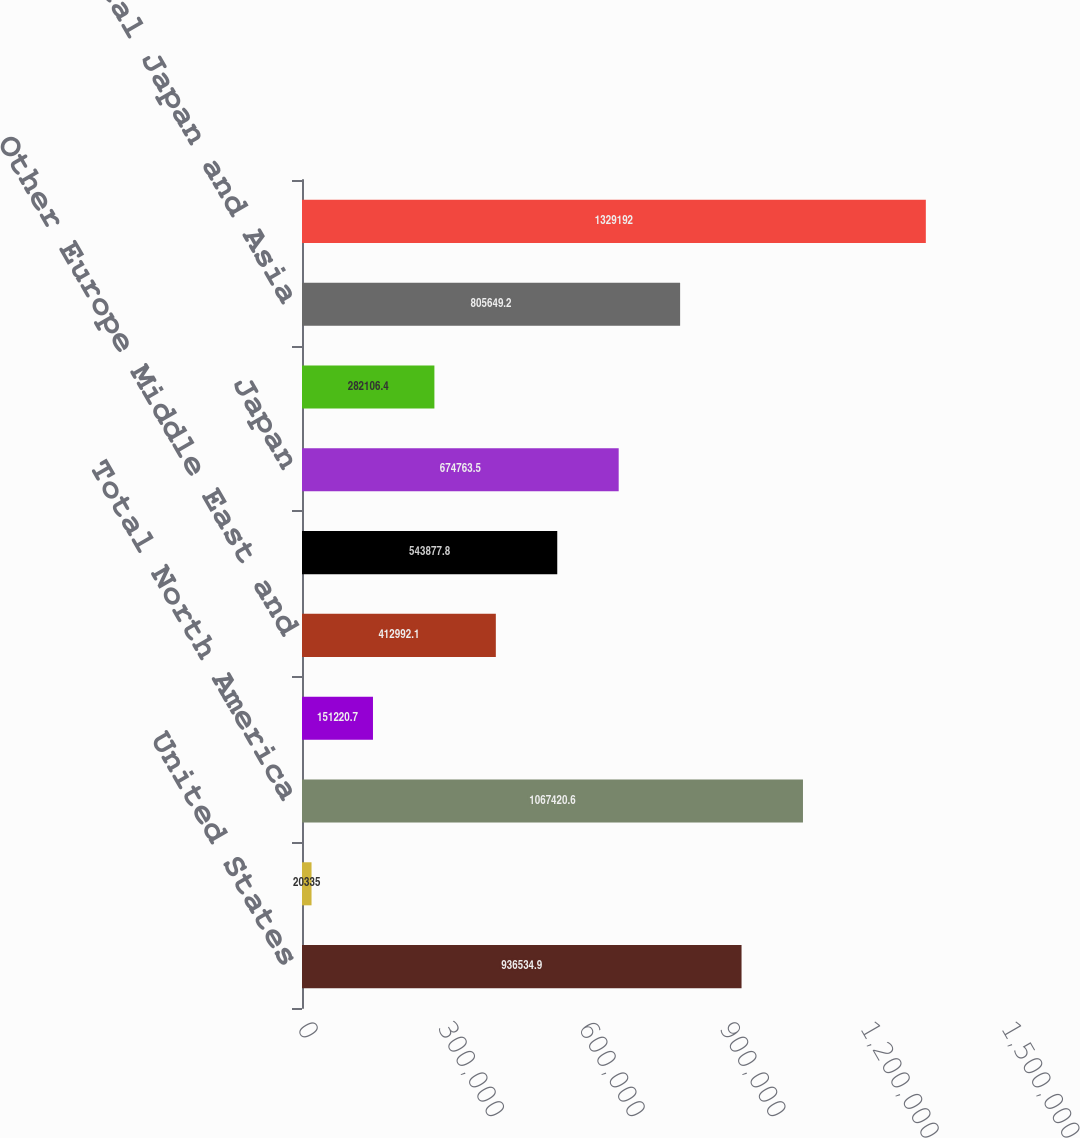<chart> <loc_0><loc_0><loc_500><loc_500><bar_chart><fcel>United States<fcel>Other North America<fcel>Total North America<fcel>Germany<fcel>Other Europe Middle East and<fcel>Total Europe Middle East and<fcel>Japan<fcel>Asia<fcel>Total Japan and Asia<fcel>Total<nl><fcel>936535<fcel>20335<fcel>1.06742e+06<fcel>151221<fcel>412992<fcel>543878<fcel>674764<fcel>282106<fcel>805649<fcel>1.32919e+06<nl></chart> 